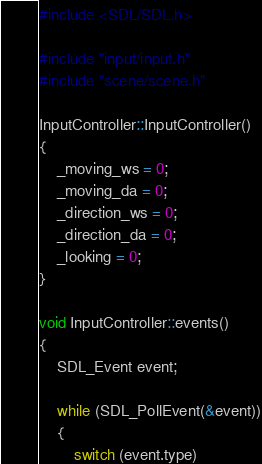<code> <loc_0><loc_0><loc_500><loc_500><_C++_>#include <SDL/SDL.h>

#include "input/input.h"
#include "scene/scene.h"

InputController::InputController()
{
	_moving_ws = 0;
	_moving_da = 0;
	_direction_ws = 0;
	_direction_da = 0;
	_looking = 0;
}

void InputController::events()
{
	SDL_Event event;

	while (SDL_PollEvent(&event))
	{
		switch (event.type)</code> 